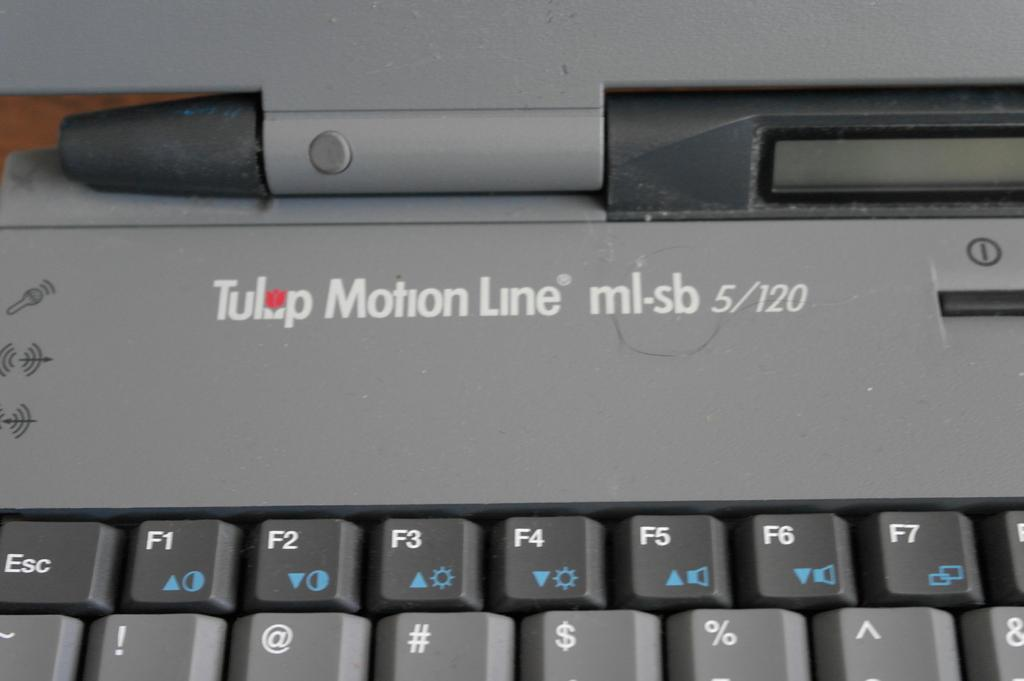<image>
Offer a succinct explanation of the picture presented. Tulip Motion Line laptop with gray keys and white symbols. 